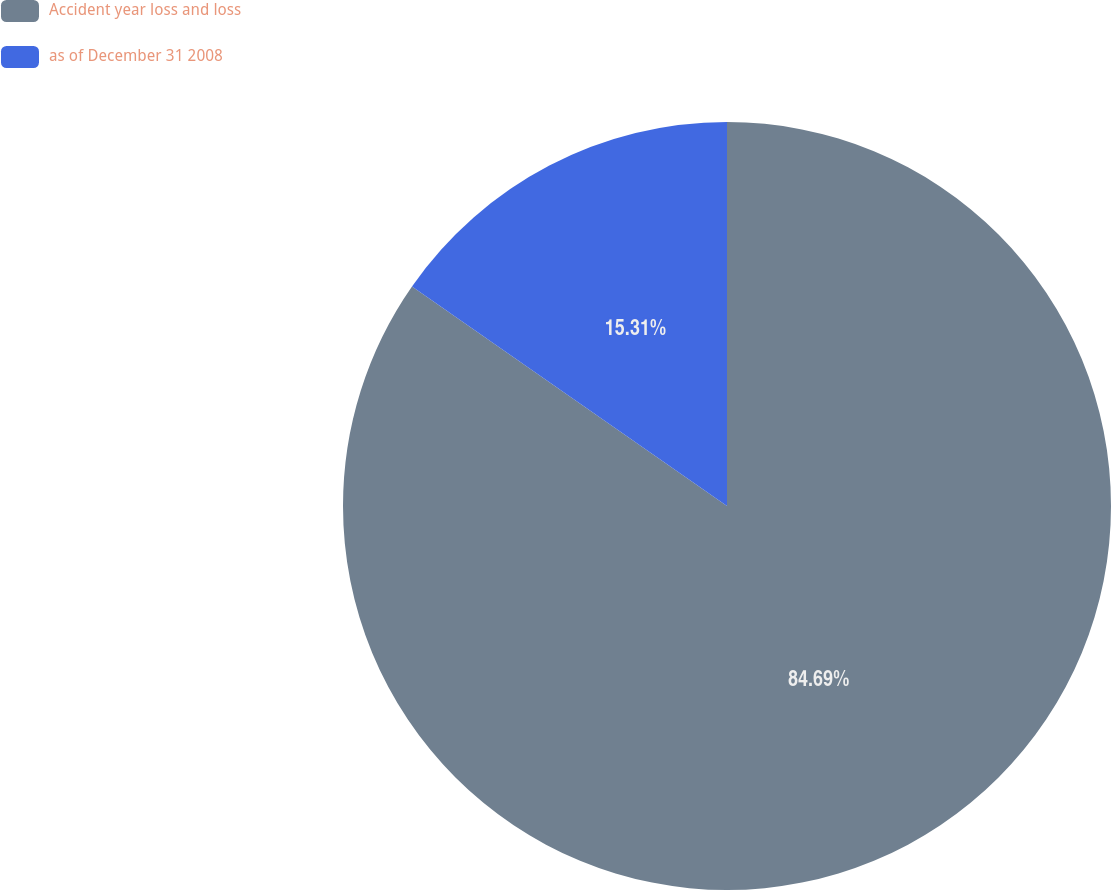Convert chart to OTSL. <chart><loc_0><loc_0><loc_500><loc_500><pie_chart><fcel>Accident year loss and loss<fcel>as of December 31 2008<nl><fcel>84.69%<fcel>15.31%<nl></chart> 